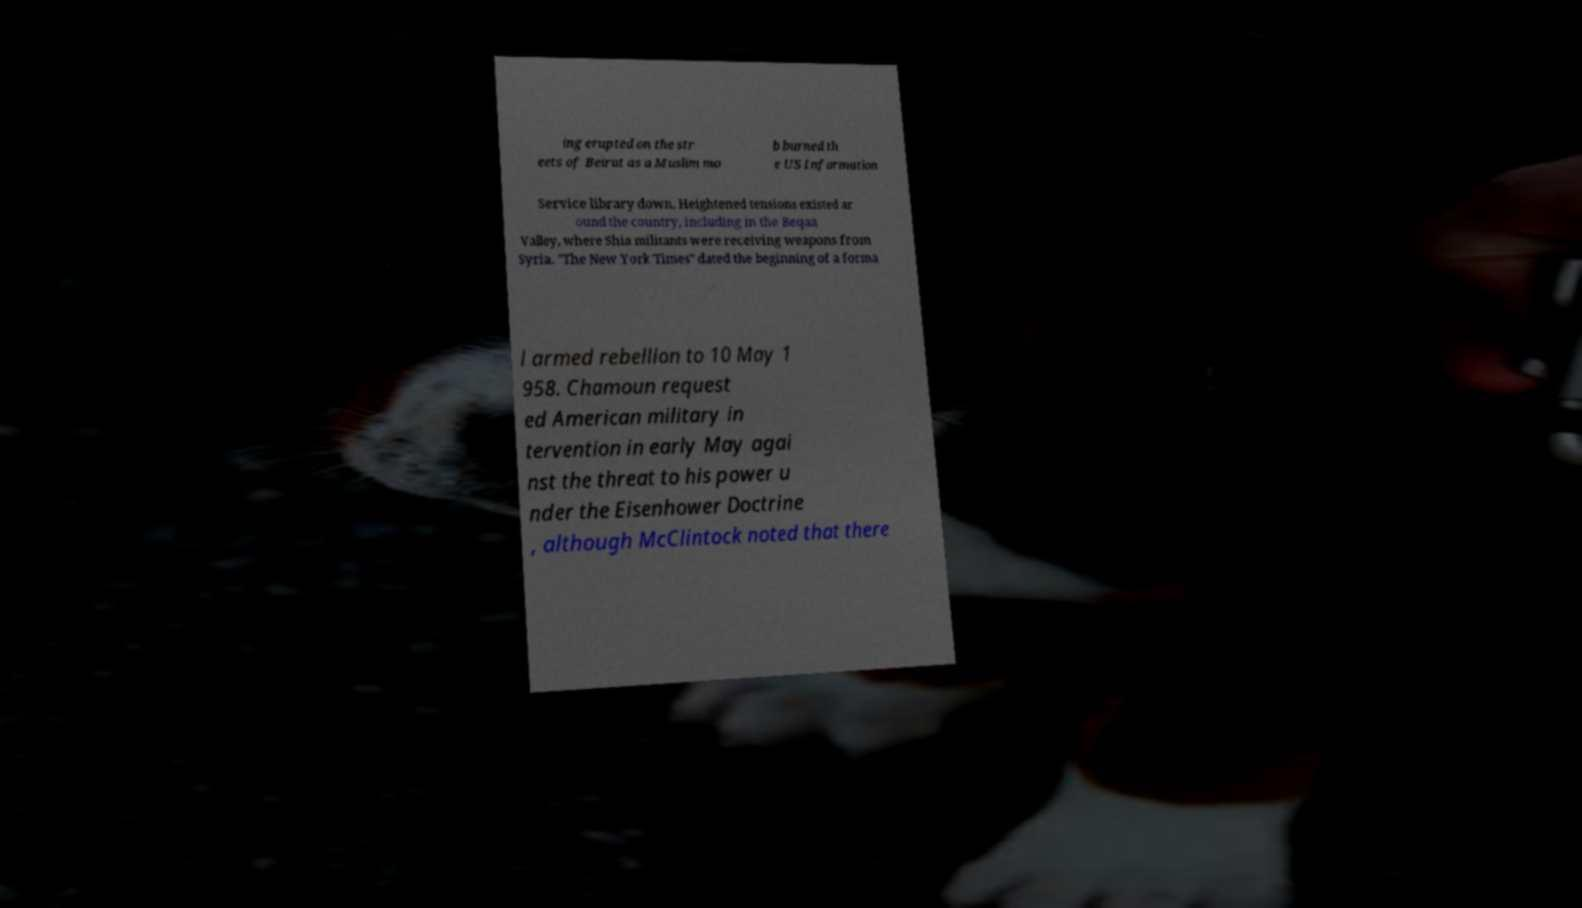For documentation purposes, I need the text within this image transcribed. Could you provide that? ing erupted on the str eets of Beirut as a Muslim mo b burned th e US Information Service library down. Heightened tensions existed ar ound the country, including in the Beqaa Valley, where Shia militants were receiving weapons from Syria. "The New York Times" dated the beginning of a forma l armed rebellion to 10 May 1 958. Chamoun request ed American military in tervention in early May agai nst the threat to his power u nder the Eisenhower Doctrine , although McClintock noted that there 